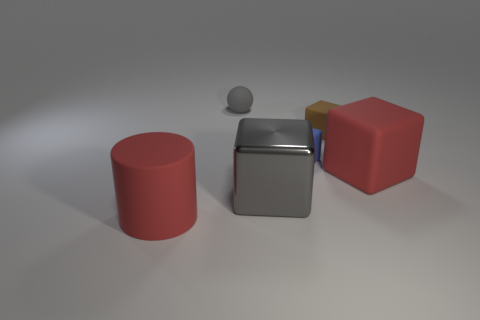What number of blue rubber things are the same size as the sphere?
Ensure brevity in your answer.  1. What is the material of the other tiny object that is the same shape as the tiny blue rubber thing?
Give a very brief answer. Rubber. What number of objects are cubes right of the small brown rubber thing or big red things that are on the right side of the small gray rubber sphere?
Your response must be concise. 1. There is a blue rubber thing; is it the same shape as the gray thing that is in front of the large matte block?
Make the answer very short. Yes. What shape is the big red object that is on the left side of the red thing on the right side of the small rubber thing that is on the left side of the shiny thing?
Ensure brevity in your answer.  Cylinder. What number of other objects are the same material as the small blue block?
Your answer should be very brief. 4. How many objects are either red things that are to the right of the red rubber cylinder or matte objects?
Offer a very short reply. 5. What shape is the red rubber object behind the matte object that is in front of the big red block?
Your answer should be compact. Cube. Do the large red object that is to the right of the small gray ball and the brown rubber thing have the same shape?
Keep it short and to the point. Yes. The thing that is on the left side of the small gray ball is what color?
Provide a succinct answer. Red. 